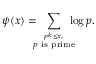Convert formula to latex. <formula><loc_0><loc_0><loc_500><loc_500>\psi ( x ) = \, \sum _ { \stackrel { p ^ { k } \leq x , } { p { i s p r i m e } } } \, \log p .</formula> 